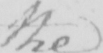What is written in this line of handwriting? the 